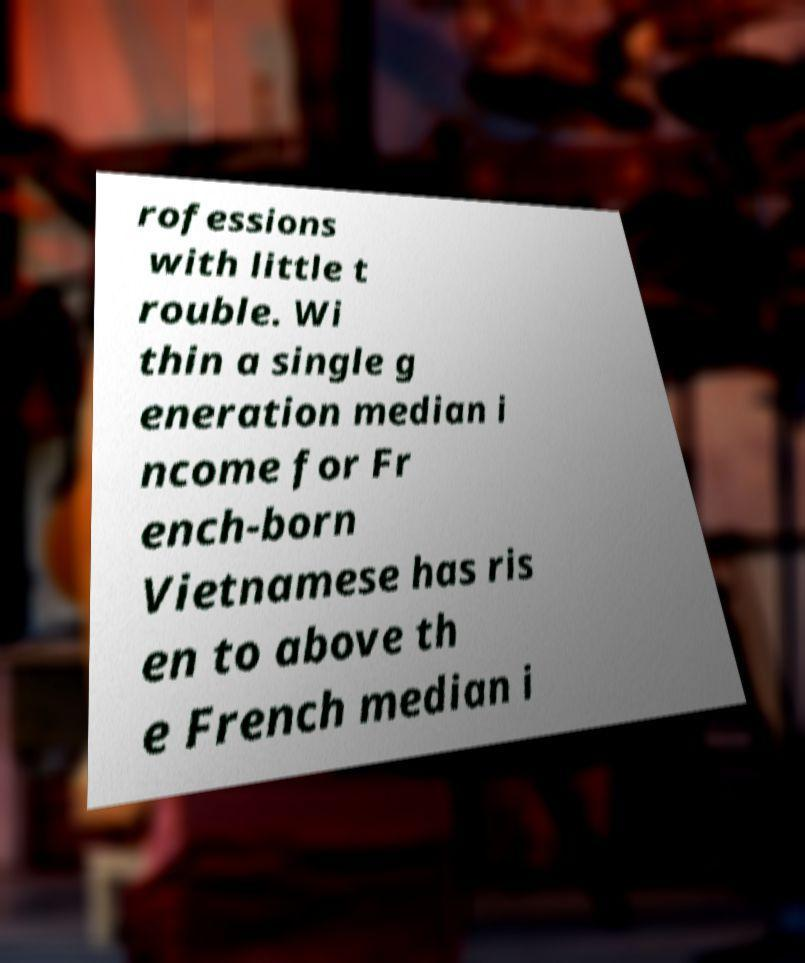I need the written content from this picture converted into text. Can you do that? rofessions with little t rouble. Wi thin a single g eneration median i ncome for Fr ench-born Vietnamese has ris en to above th e French median i 